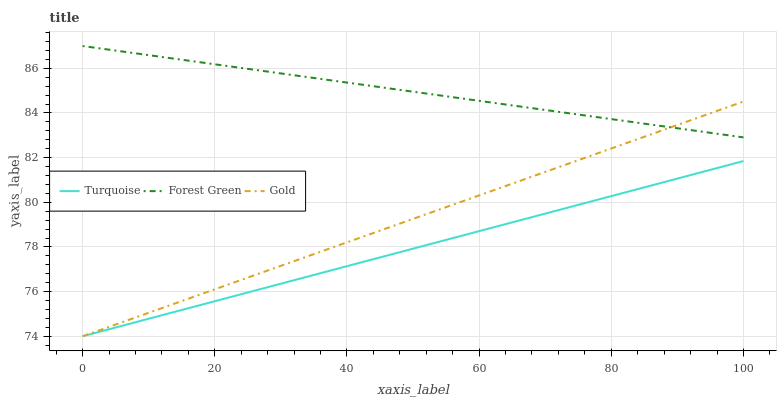Does Turquoise have the minimum area under the curve?
Answer yes or no. Yes. Does Forest Green have the maximum area under the curve?
Answer yes or no. Yes. Does Gold have the minimum area under the curve?
Answer yes or no. No. Does Gold have the maximum area under the curve?
Answer yes or no. No. Is Gold the smoothest?
Answer yes or no. Yes. Is Forest Green the roughest?
Answer yes or no. Yes. Is Forest Green the smoothest?
Answer yes or no. No. Is Gold the roughest?
Answer yes or no. No. Does Turquoise have the lowest value?
Answer yes or no. Yes. Does Forest Green have the lowest value?
Answer yes or no. No. Does Forest Green have the highest value?
Answer yes or no. Yes. Does Gold have the highest value?
Answer yes or no. No. Is Turquoise less than Forest Green?
Answer yes or no. Yes. Is Forest Green greater than Turquoise?
Answer yes or no. Yes. Does Gold intersect Forest Green?
Answer yes or no. Yes. Is Gold less than Forest Green?
Answer yes or no. No. Is Gold greater than Forest Green?
Answer yes or no. No. Does Turquoise intersect Forest Green?
Answer yes or no. No. 